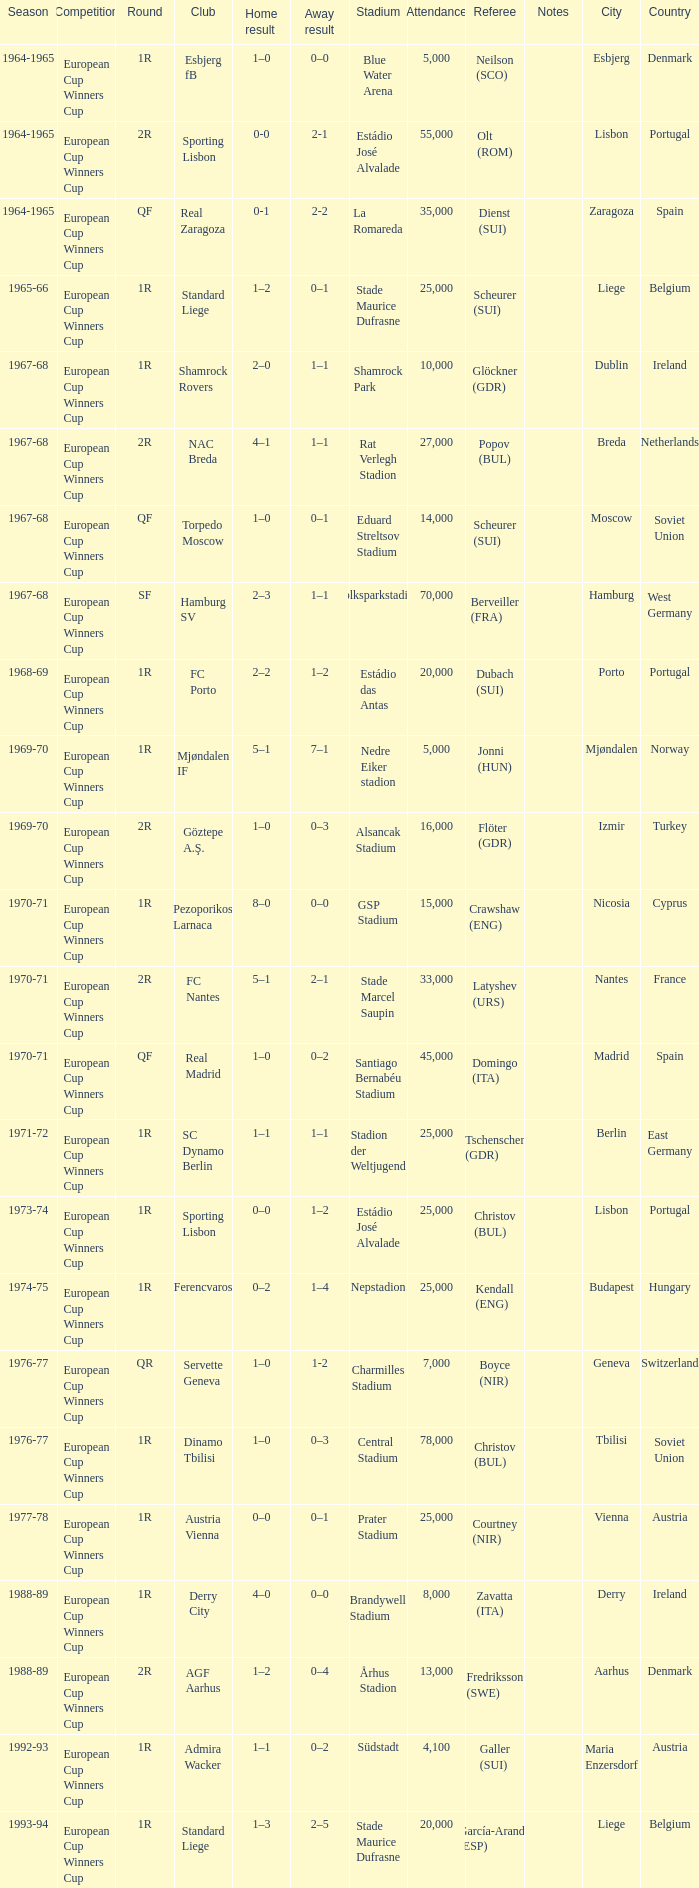Home result of 1–0, and a Away result of 0–1 involves what club? Torpedo Moscow. 